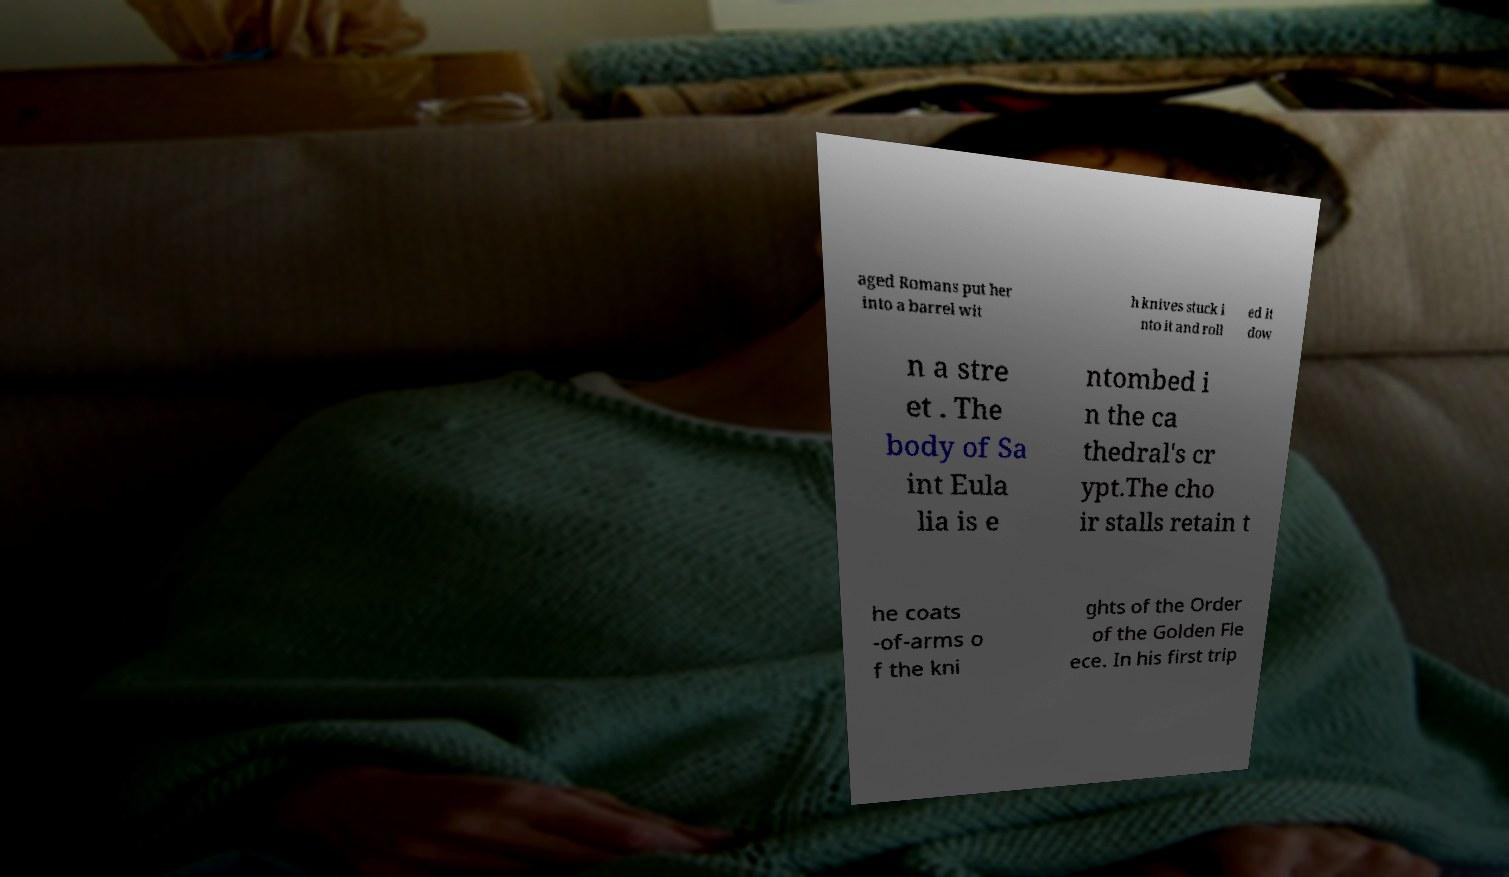Please identify and transcribe the text found in this image. aged Romans put her into a barrel wit h knives stuck i nto it and roll ed it dow n a stre et . The body of Sa int Eula lia is e ntombed i n the ca thedral's cr ypt.The cho ir stalls retain t he coats -of-arms o f the kni ghts of the Order of the Golden Fle ece. In his first trip 